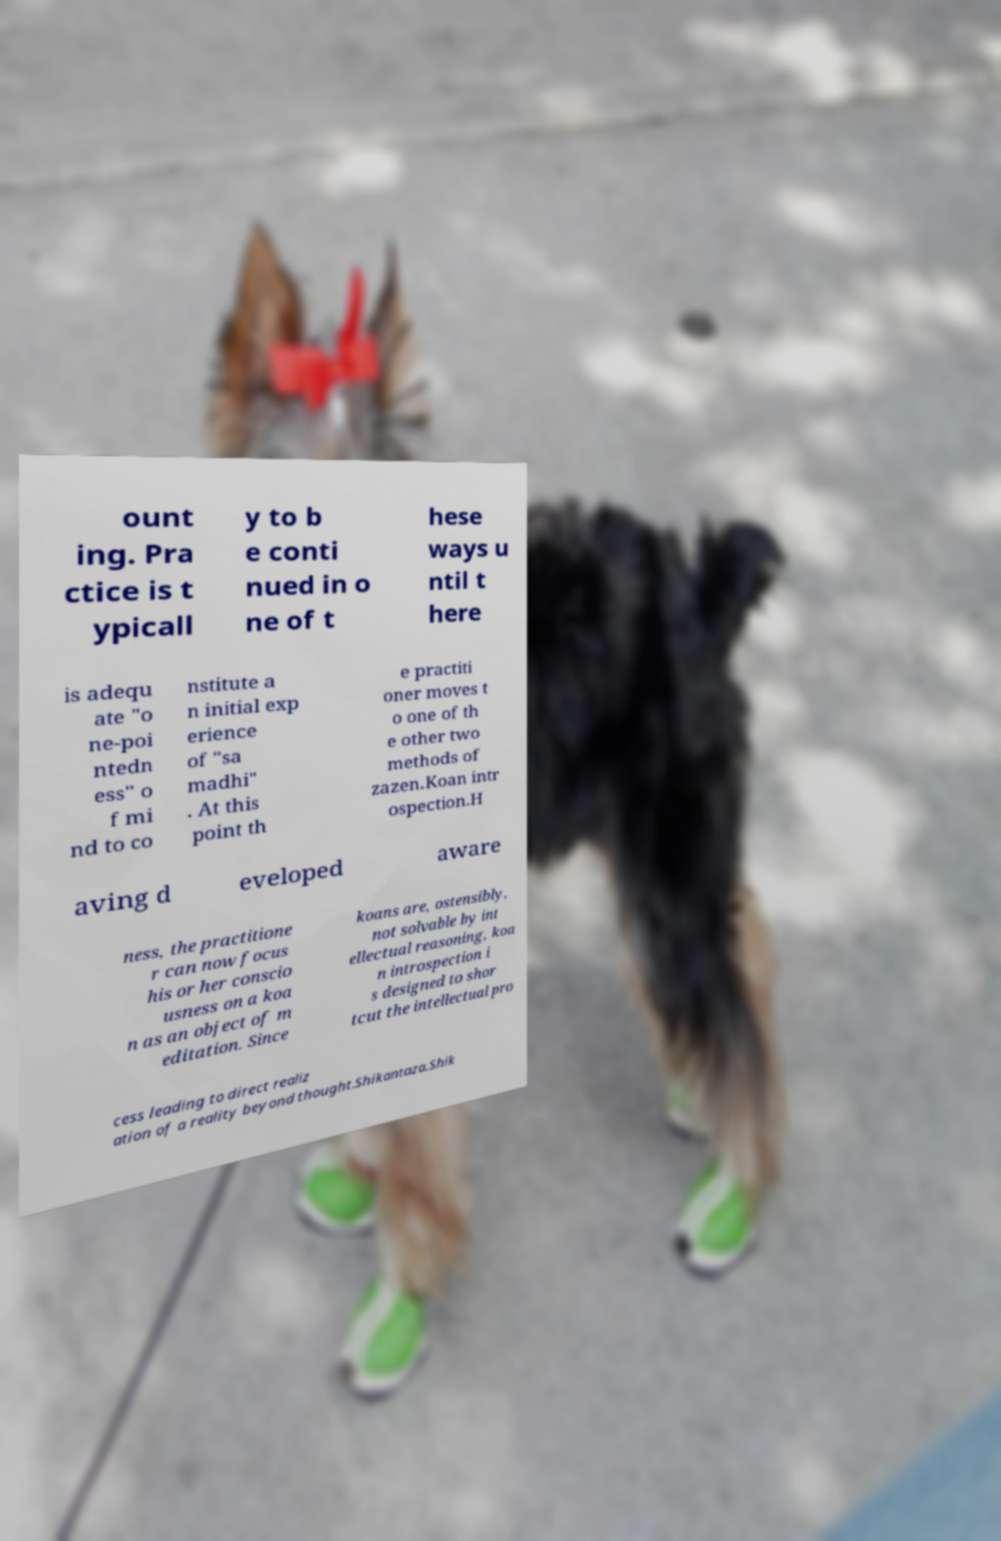Please identify and transcribe the text found in this image. ount ing. Pra ctice is t ypicall y to b e conti nued in o ne of t hese ways u ntil t here is adequ ate "o ne-poi ntedn ess" o f mi nd to co nstitute a n initial exp erience of "sa madhi" . At this point th e practiti oner moves t o one of th e other two methods of zazen.Koan intr ospection.H aving d eveloped aware ness, the practitione r can now focus his or her conscio usness on a koa n as an object of m editation. Since koans are, ostensibly, not solvable by int ellectual reasoning, koa n introspection i s designed to shor tcut the intellectual pro cess leading to direct realiz ation of a reality beyond thought.Shikantaza.Shik 